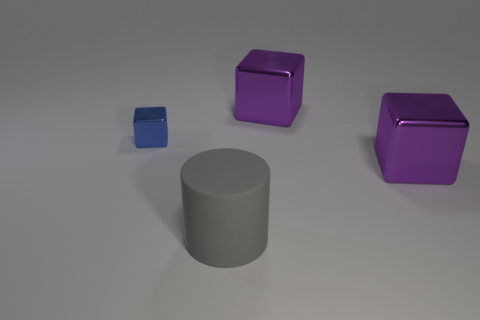Is there anything else that is the same material as the large gray cylinder?
Make the answer very short. No. Is the number of large gray rubber cylinders that are left of the big gray rubber cylinder less than the number of small blue things that are behind the small blue thing?
Give a very brief answer. No. What number of things are large blue cylinders or blocks that are to the left of the large matte cylinder?
Your answer should be very brief. 1. Do the blue cube and the large gray cylinder have the same material?
Make the answer very short. No. What color is the large object that is in front of the small blue cube and on the right side of the gray rubber cylinder?
Provide a short and direct response. Purple. There is a shiny thing that is left of the rubber object; does it have the same color as the matte cylinder?
Provide a succinct answer. No. What number of other objects are the same color as the tiny shiny block?
Your answer should be very brief. 0. What number of other things are there of the same material as the large gray thing
Your response must be concise. 0. There is a blue metallic block; is its size the same as the purple thing that is behind the blue metallic thing?
Provide a short and direct response. No. The big matte object is what color?
Make the answer very short. Gray. 